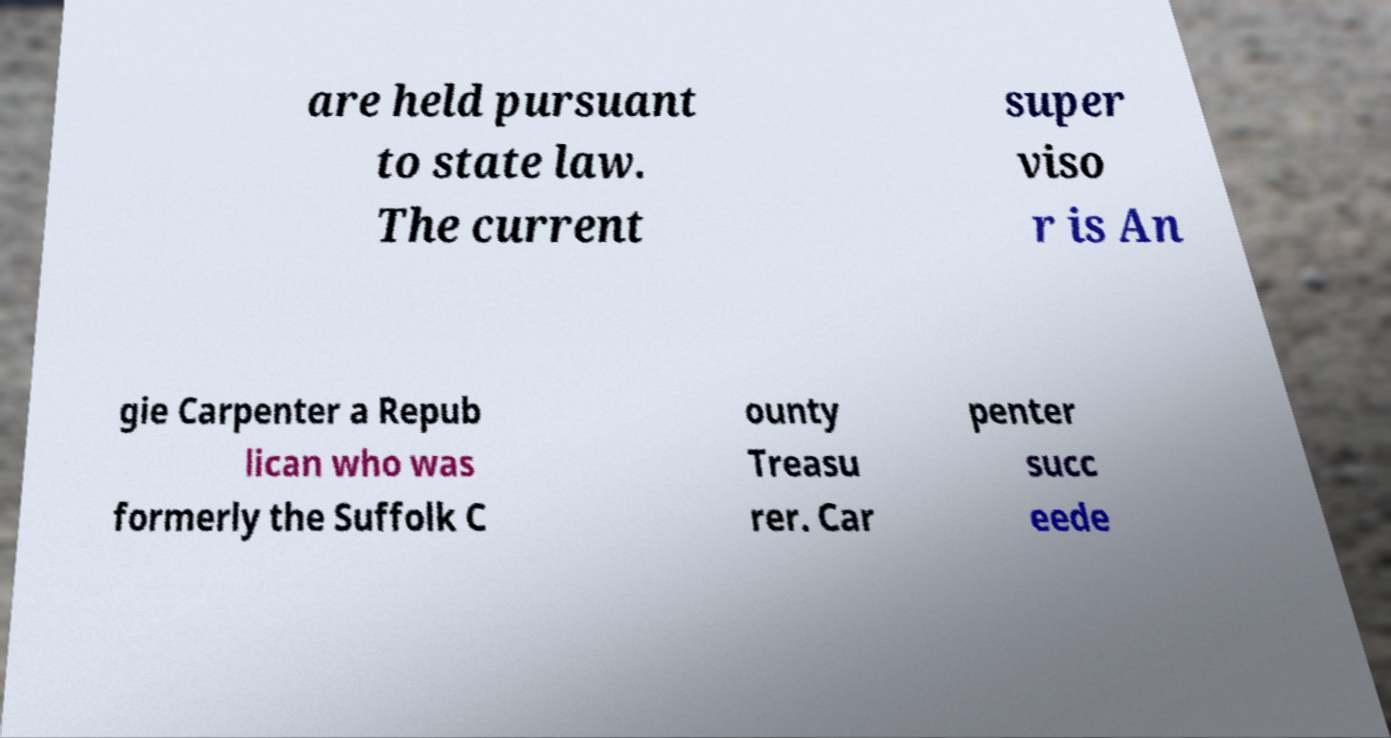Can you read and provide the text displayed in the image?This photo seems to have some interesting text. Can you extract and type it out for me? are held pursuant to state law. The current super viso r is An gie Carpenter a Repub lican who was formerly the Suffolk C ounty Treasu rer. Car penter succ eede 